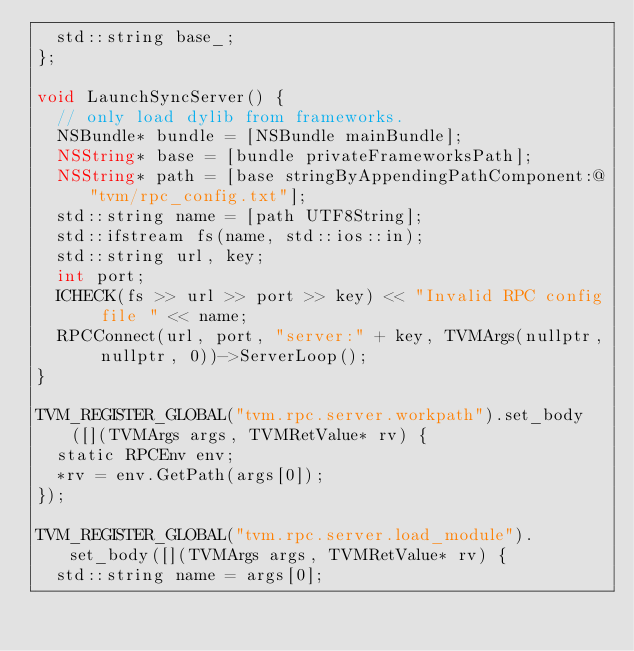Convert code to text. <code><loc_0><loc_0><loc_500><loc_500><_ObjectiveC_>  std::string base_;
};

void LaunchSyncServer() {
  // only load dylib from frameworks.
  NSBundle* bundle = [NSBundle mainBundle];
  NSString* base = [bundle privateFrameworksPath];
  NSString* path = [base stringByAppendingPathComponent:@"tvm/rpc_config.txt"];
  std::string name = [path UTF8String];
  std::ifstream fs(name, std::ios::in);
  std::string url, key;
  int port;
  ICHECK(fs >> url >> port >> key) << "Invalid RPC config file " << name;
  RPCConnect(url, port, "server:" + key, TVMArgs(nullptr, nullptr, 0))->ServerLoop();
}

TVM_REGISTER_GLOBAL("tvm.rpc.server.workpath").set_body([](TVMArgs args, TVMRetValue* rv) {
  static RPCEnv env;
  *rv = env.GetPath(args[0]);
});

TVM_REGISTER_GLOBAL("tvm.rpc.server.load_module").set_body([](TVMArgs args, TVMRetValue* rv) {
  std::string name = args[0];</code> 